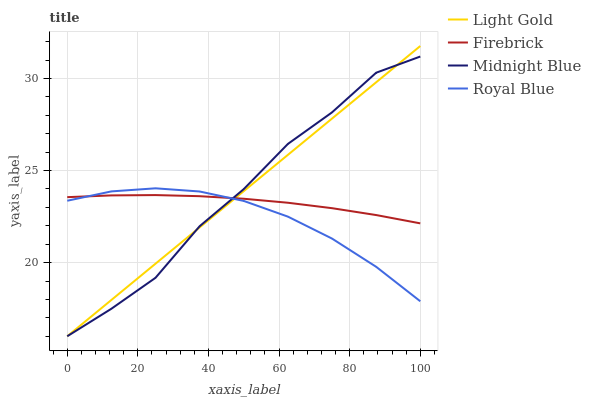Does Royal Blue have the minimum area under the curve?
Answer yes or no. Yes. Does Midnight Blue have the maximum area under the curve?
Answer yes or no. Yes. Does Firebrick have the minimum area under the curve?
Answer yes or no. No. Does Firebrick have the maximum area under the curve?
Answer yes or no. No. Is Light Gold the smoothest?
Answer yes or no. Yes. Is Midnight Blue the roughest?
Answer yes or no. Yes. Is Firebrick the smoothest?
Answer yes or no. No. Is Firebrick the roughest?
Answer yes or no. No. Does Light Gold have the lowest value?
Answer yes or no. Yes. Does Firebrick have the lowest value?
Answer yes or no. No. Does Light Gold have the highest value?
Answer yes or no. Yes. Does Firebrick have the highest value?
Answer yes or no. No. Does Firebrick intersect Light Gold?
Answer yes or no. Yes. Is Firebrick less than Light Gold?
Answer yes or no. No. Is Firebrick greater than Light Gold?
Answer yes or no. No. 